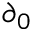<formula> <loc_0><loc_0><loc_500><loc_500>\partial _ { 0 }</formula> 